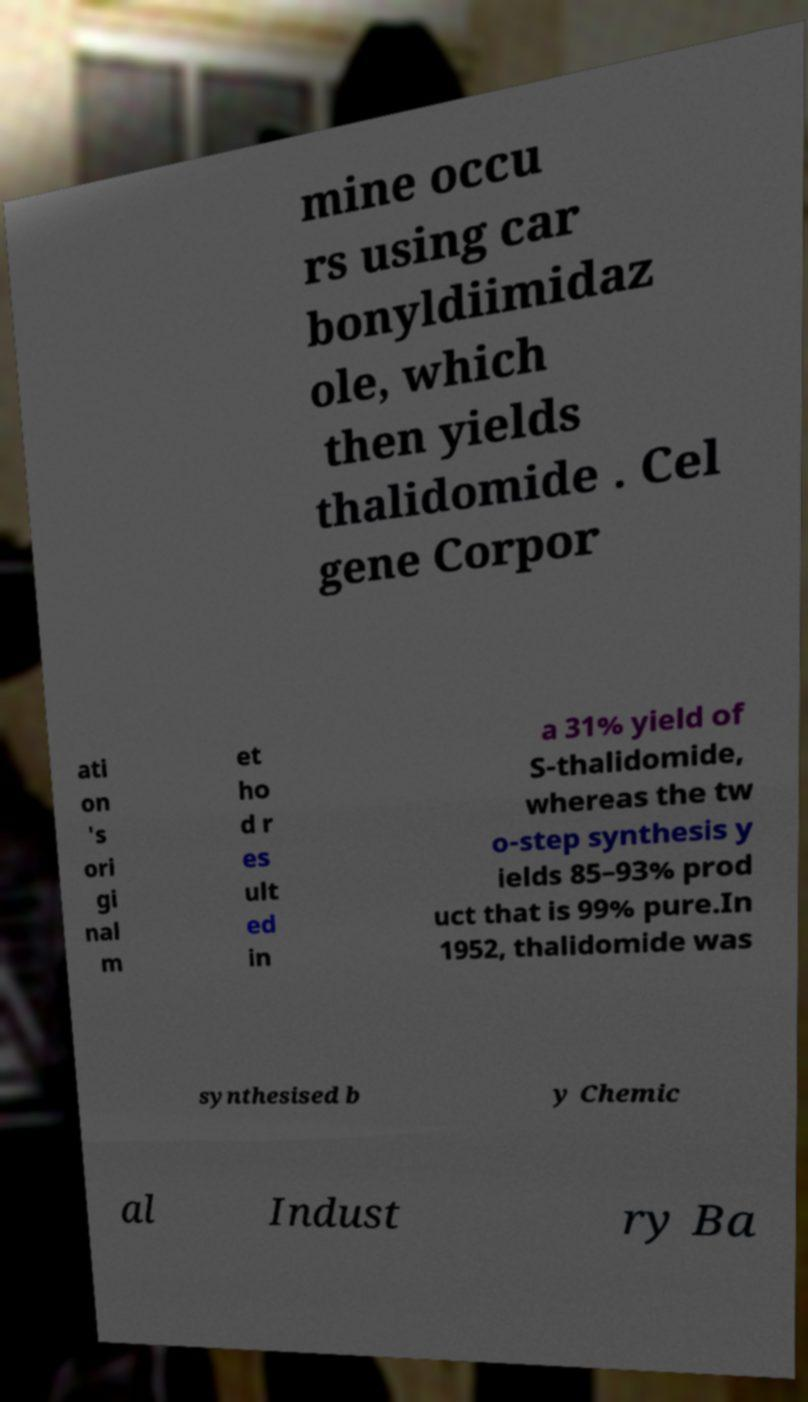Could you extract and type out the text from this image? mine occu rs using car bonyldiimidaz ole, which then yields thalidomide . Cel gene Corpor ati on 's ori gi nal m et ho d r es ult ed in a 31% yield of S-thalidomide, whereas the tw o-step synthesis y ields 85–93% prod uct that is 99% pure.In 1952, thalidomide was synthesised b y Chemic al Indust ry Ba 